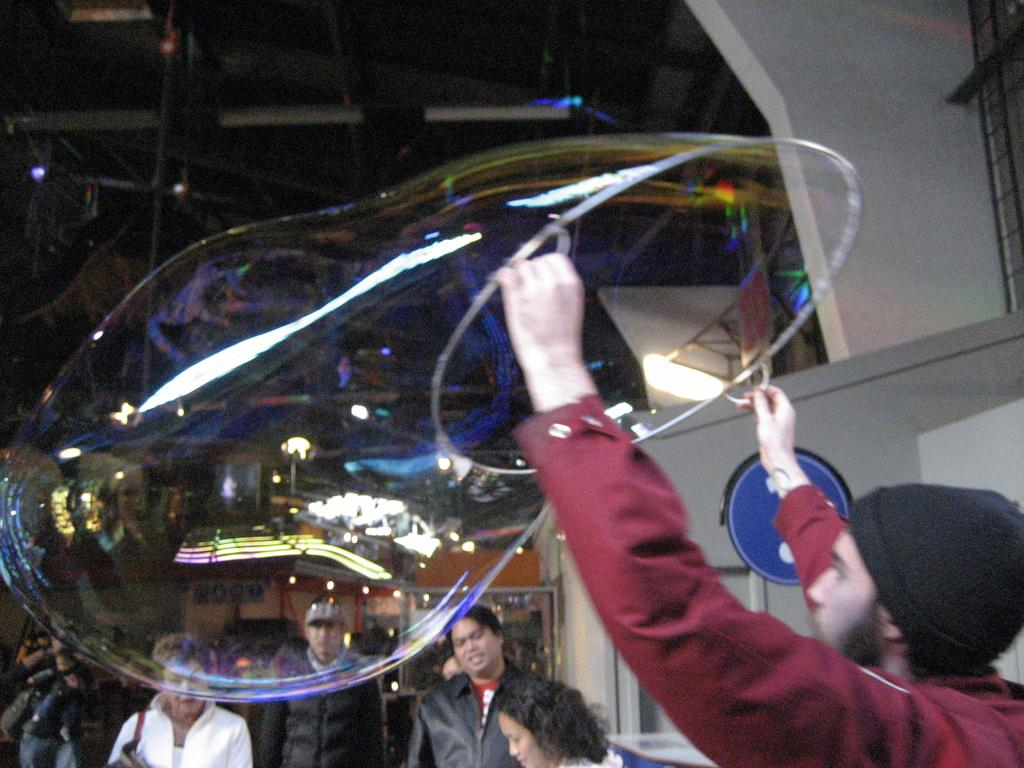What is the man in the image holding? The man is holding an object in the image. Can you describe anything else about the object? Unfortunately, the facts provided do not give any additional details about the object. What can be seen in the background of the image? In the background of the image, there is a crowd, a wall, and lights. What might the lights be used for? The lights in the background could be used for illumination or decoration. How many pigs are visible in the image? There are no pigs present in the image. What type of support does the object provide in the image? The facts provided do not give any information about the object's function or purpose. 